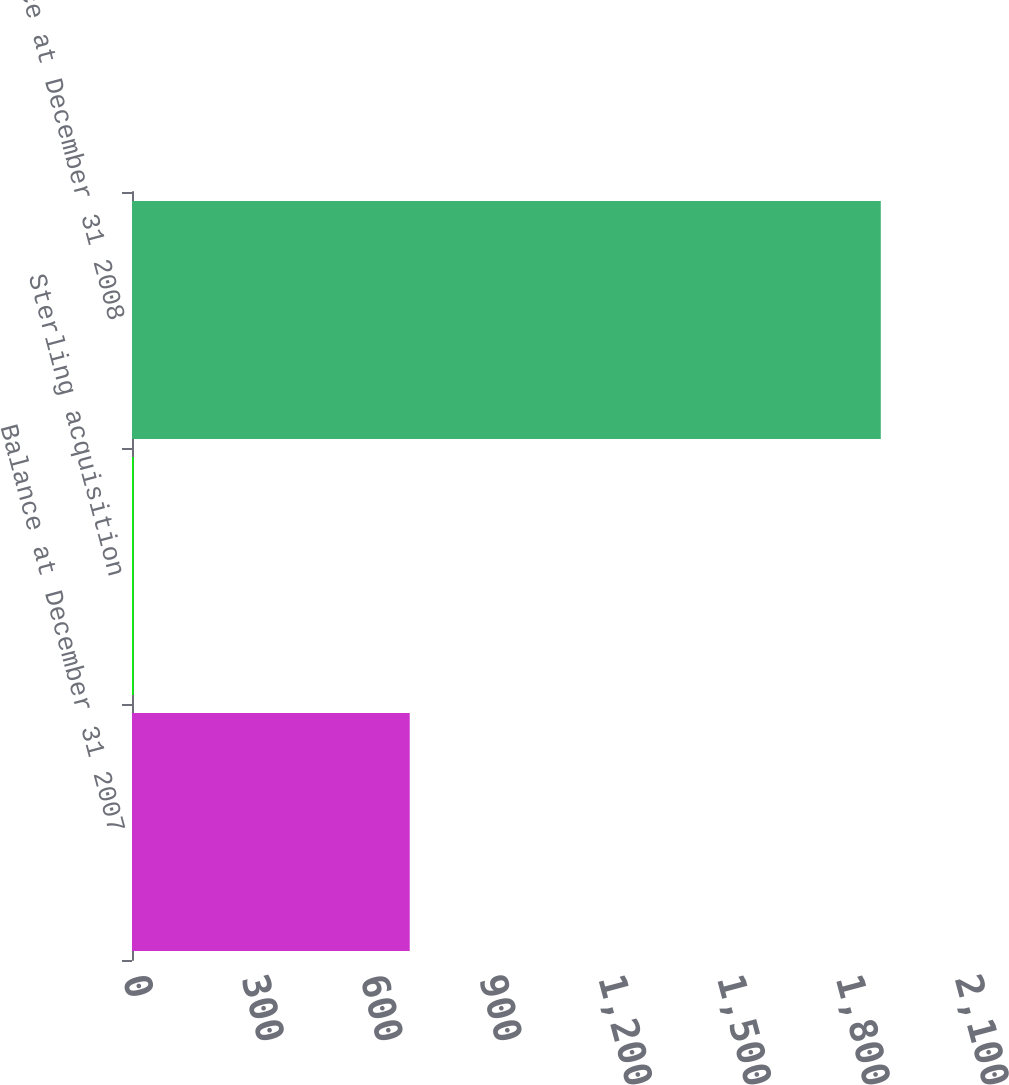<chart> <loc_0><loc_0><loc_500><loc_500><bar_chart><fcel>Balance at December 31 2007<fcel>Sterling acquisition<fcel>Balance at December 31 2008<nl><fcel>701<fcel>4<fcel>1890<nl></chart> 